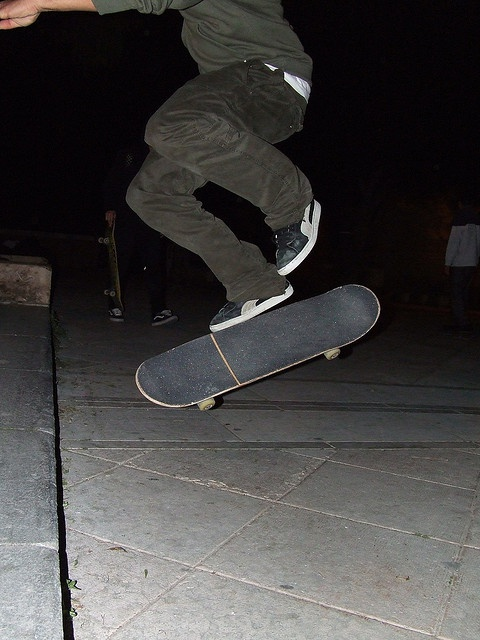Describe the objects in this image and their specific colors. I can see people in black and gray tones, skateboard in black and gray tones, people in black and gray tones, and skateboard in black and gray tones in this image. 